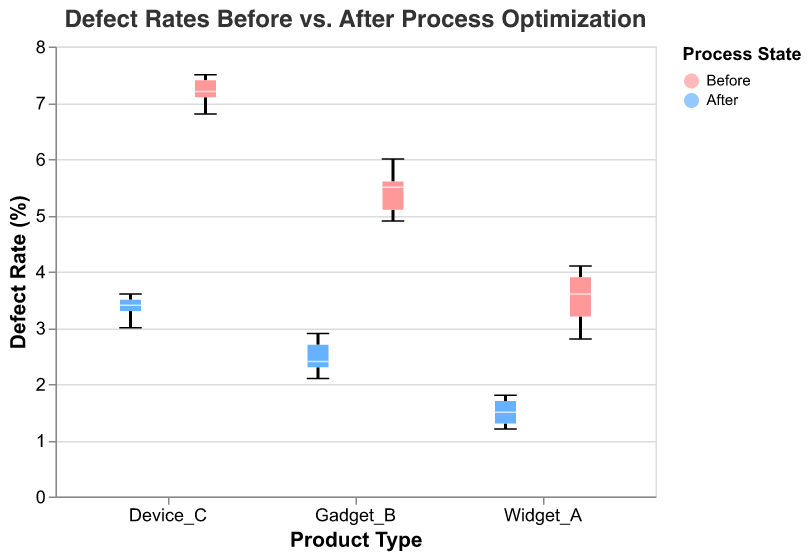What is the overall title of the figure? The title is usually found at the top of the figure and is meant to give a concise description of what the plot represents. In this case, it states: "Defect Rates Before vs. After Process Optimization".
Answer: Defect Rates Before vs. After Process Optimization What does the y-axis represent in the figure? The y-axis typically labels the dependent variable in a plot. In this case, the label reads "Defect Rate (%)", which indicates it quantifies the percentage of defect rates.
Answer: Defect Rate (%) What is the range of the y-axis? The range of the y-axis is determined by the minimum and maximum values displayed on it. Here, the axis ranges from 0 to 8 as indicated by the domain specified in the figure settings.
Answer: 0 to 8 What are the colors used to differentiate the states "Before" and "After"? The legend in the plot explains the color scheme. "Before" is represented by a shade of red (#FF9999), and "After" is represented by a shade of blue (#66B2FF).
Answer: Red and Blue How does the average defect rate for Widget_A change after process optimization? The average defect rate can be determined by comparing the central tendency (mean or median) of the "Before" and "After" box plots for Widget_A. The median defect rate decreases considerably from the "Before" state to the "After" state.
Answer: Decreases What is the maximum defect rate for Device_C before process optimization? The maximum defect rate for any product "Before" the process optimization is represented by the topmost point in the "Before" box plot for that product. For Device_C, it appears to be roughly 7.5%.
Answer: 7.5% Which product shows the greatest decrease in median defect rate after process optimization? To find the greatest decrease in median defect rate, compare the drop from "Before" to "After" for each product. The median lines in the box plots for Device_C show the largest decline, from around 7.2% to about 3.4%.
Answer: Device_C What is the interquartile range (IQR) for Gadget_B before process optimization? The IQR is found by subtracting the first quartile (Q1) from the third quartile (Q3). For Gadget_B "Before", Q3 is around 5.6% and Q1 is around 5.0%, so the IQR is 5.6% - 5.0% = 0.6%.
Answer: 0.6% Is there any overlap in defect rates between the before and after states for Widget_A? Observing the box plots for Widget_A, check if the whiskers (min-max range lines) overlap. There is no overlap, indicating complete separation between the "Before" and "After" defect rates for Widget_A.
Answer: No How does the variability of defect rates change for Gadget_B after process optimization? Variability can be assessed by looking at the spread of the 'After' box plot for Gadget_B. The box plot shows a smaller range in the "After" state, indicating reduced variability compared to "Before".
Answer: Reduced 